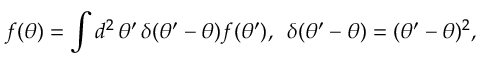<formula> <loc_0><loc_0><loc_500><loc_500>f ( \theta ) = \int d ^ { 2 } \, \theta ^ { \prime } \, \delta ( \theta ^ { \prime } - \theta ) f ( \theta ^ { \prime } ) , \, \delta ( \theta ^ { \prime } - \theta ) = ( \theta ^ { \prime } - \theta ) ^ { 2 } ,</formula> 